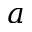<formula> <loc_0><loc_0><loc_500><loc_500>a</formula> 